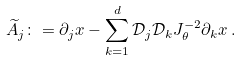<formula> <loc_0><loc_0><loc_500><loc_500>\widetilde { A } _ { j } \colon = \partial _ { j } x - \sum _ { k = 1 } ^ { d } { \mathcal { D } } _ { j } { \mathcal { D } } _ { k } J _ { \theta } ^ { - 2 } \partial _ { k } x \, .</formula> 